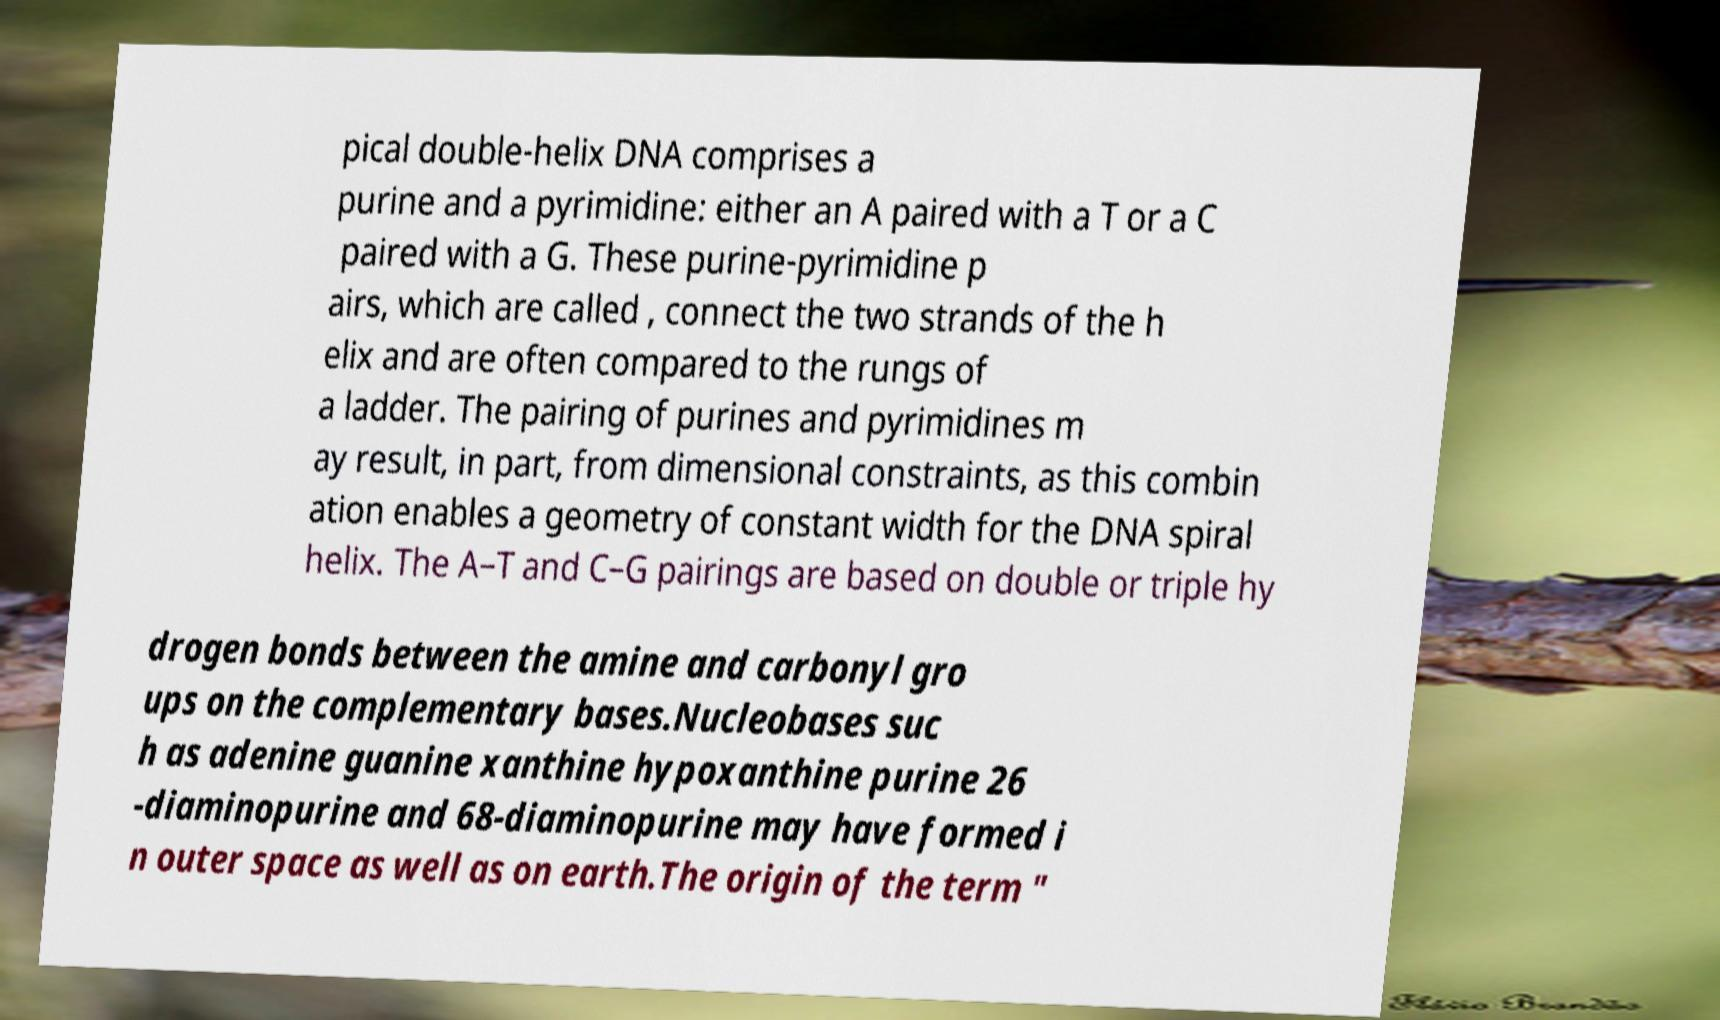For documentation purposes, I need the text within this image transcribed. Could you provide that? pical double-helix DNA comprises a purine and a pyrimidine: either an A paired with a T or a C paired with a G. These purine-pyrimidine p airs, which are called , connect the two strands of the h elix and are often compared to the rungs of a ladder. The pairing of purines and pyrimidines m ay result, in part, from dimensional constraints, as this combin ation enables a geometry of constant width for the DNA spiral helix. The A–T and C–G pairings are based on double or triple hy drogen bonds between the amine and carbonyl gro ups on the complementary bases.Nucleobases suc h as adenine guanine xanthine hypoxanthine purine 26 -diaminopurine and 68-diaminopurine may have formed i n outer space as well as on earth.The origin of the term " 